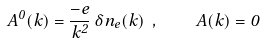Convert formula to latex. <formula><loc_0><loc_0><loc_500><loc_500>A ^ { 0 } ( k ) = \frac { - e } { \vec { k } ^ { 2 } } \, \delta n _ { e } ( k ) \ , \quad \vec { A } ( k ) = \vec { 0 }</formula> 